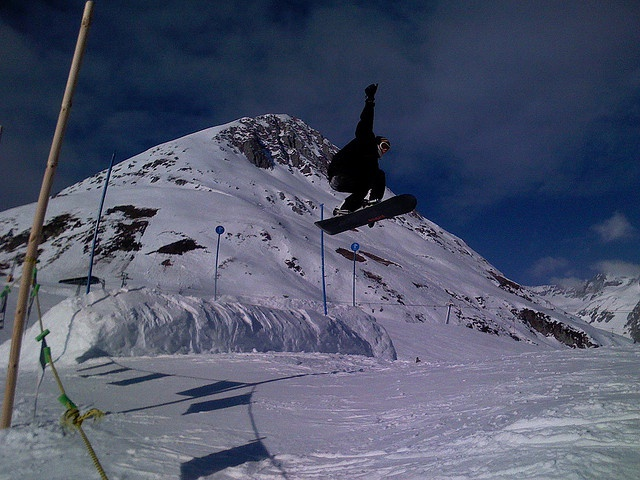Describe the objects in this image and their specific colors. I can see people in black, gray, and darkgray tones and snowboard in black, gray, navy, and maroon tones in this image. 